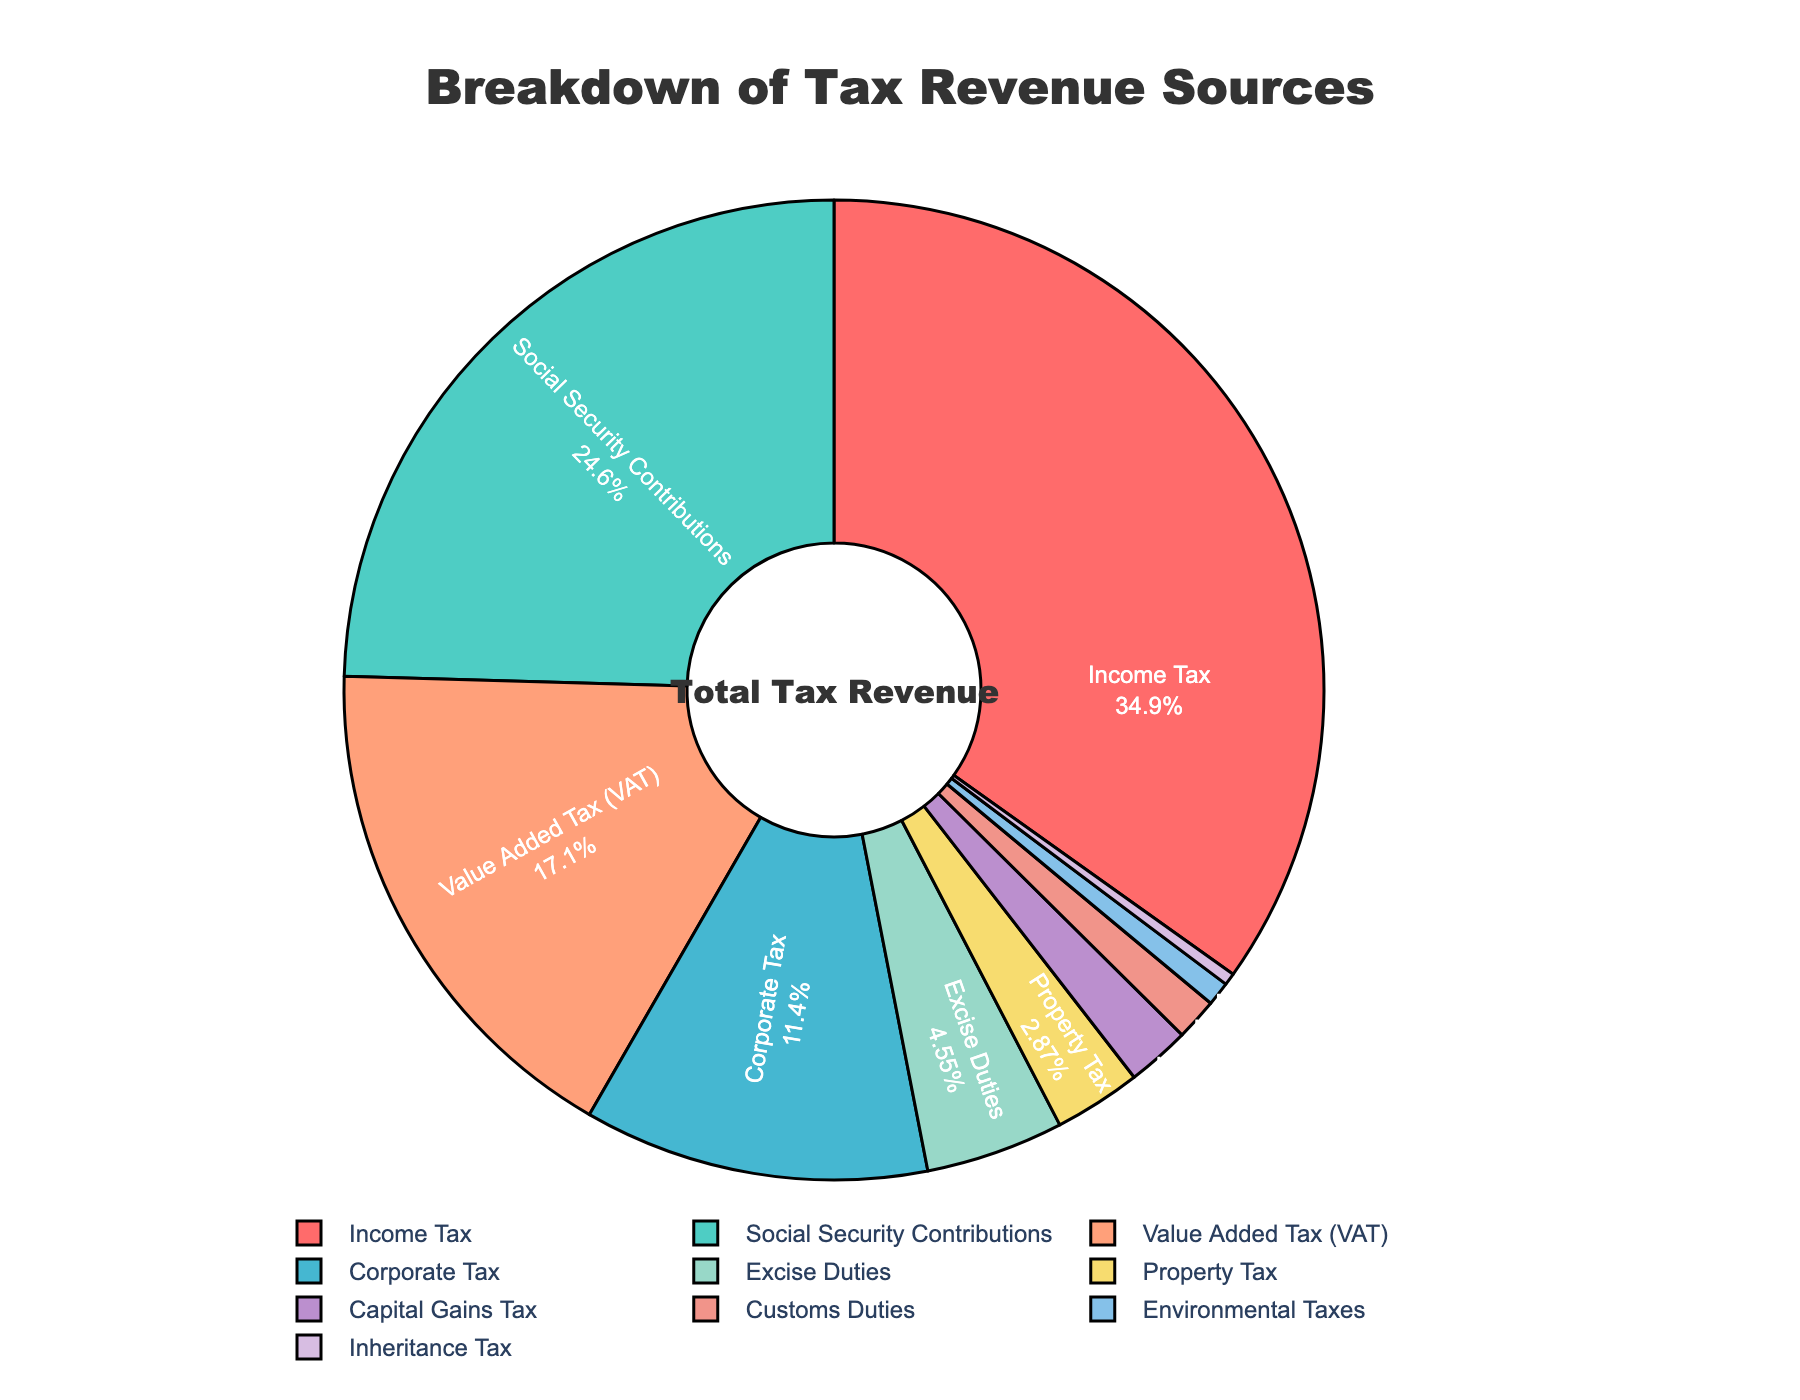Which tax category has the highest percentage? The tax category with the highest percentage can be identified by looking at the section of the pie chart with the largest size. "Income Tax" occupies the largest part.
Answer: Income Tax What is the combined percentage of Value Added Tax (VAT) and Excise Duties? Add the percentages of Value Added Tax (17.3%) and Excise Duties (4.6%). Calculation: 17.3 + 4.6 = 21.9%
Answer: 21.9% Which tax categories together make up over 50% of the total tax revenue? Sum up the largest categories until the sum exceeds 50%. Income Tax (35.2%) + Social Security Contributions (24.8%) = 60%, which is over half.
Answer: Income Tax and Social Security Contributions Is the percentage from Property Tax higher, lower, or equal to Customs Duties? Compare the percentages of Property Tax (2.9%) and Customs Duties (1.4%). 2.9% is higher than 1.4%.
Answer: Higher What tax categories together contribute to nearly 80% of the total tax revenue? We sum the largest categories until the sum is close to 80%. Income Tax (35.2%) + Social Security Contributions (24.8%) + Value Added Tax (17.3%) + Corporate Tax (11.5%) = 88.8%, which is closest to 80% without exceeding by a large margin.
Answer: Income Tax, Social Security Contributions, Value Added Tax, and Corporate Tax What is the visual attribute (color) used for the category with the lowest percentage? The category with the lowest percentage is Inheritance Tax (0.4%), and we locate the color of its section on the pie chart. It is a shade of purple.
Answer: Purple How much more (in percentage points) does Corporate Tax contribute compared to Capital Gains Tax? Subtract the percentage of Capital Gains Tax (2.1%) from Corporate Tax (11.5%). Calculation: 11.5 - 2.1 = 9.4 percentage points more.
Answer: 9.4 percentage points Which two categories together have a very similar percentage to Income Tax alone? Find two categories whose combined percentages are close to 35.2%. Social Security Contributions (24.8%) + Value Added Tax (17.3%) = 42.1%, which is fairly close.
Answer: Social Security Contributions and Value Added Tax What can be inferred about the relative size of Environmental Taxes compared to Inheritance Tax? Compared their percentages: Environmental Taxes (0.8%) vs. Inheritance Tax (0.4%). Environmental Taxes occupy a larger area in the chart.
Answer: Environmental Taxes are larger What are the colors used for Income Tax and Corporate Tax categories in the pie chart? Identify the sections for Income Tax (largest section) and Corporate Tax, and observe their colors. Income Tax is red, while Corporate Tax is greenish-blue.
Answer: Income Tax: red; Corporate Tax: greenish-blue 